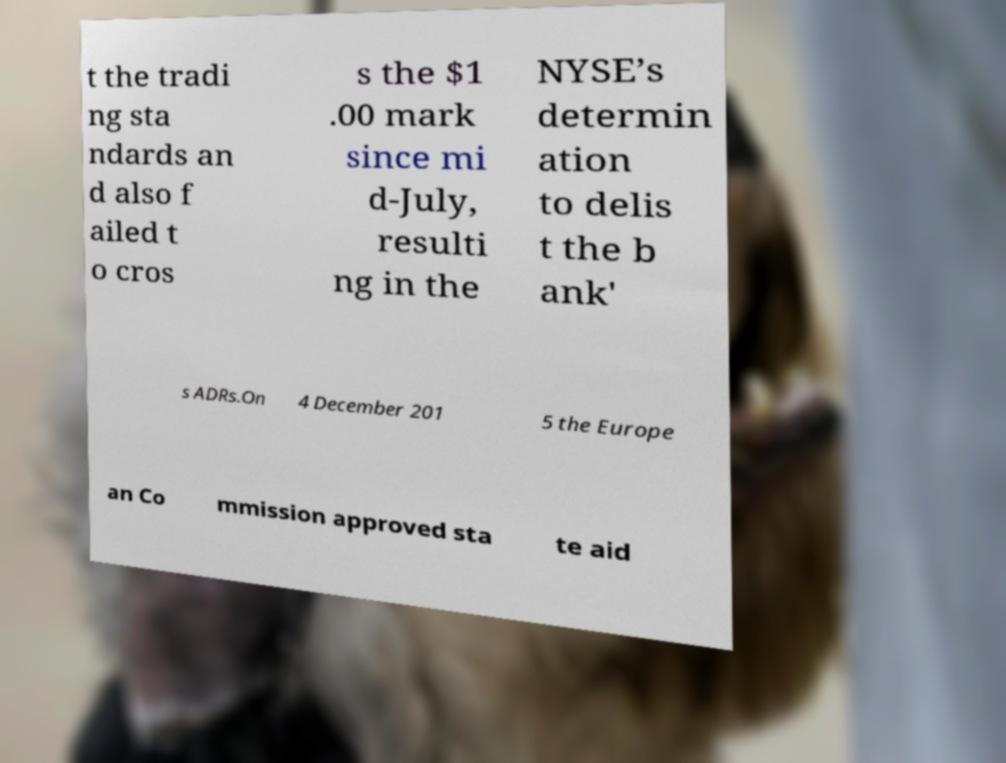There's text embedded in this image that I need extracted. Can you transcribe it verbatim? t the tradi ng sta ndards an d also f ailed t o cros s the $1 .00 mark since mi d-July, resulti ng in the NYSE’s determin ation to delis t the b ank' s ADRs.On 4 December 201 5 the Europe an Co mmission approved sta te aid 